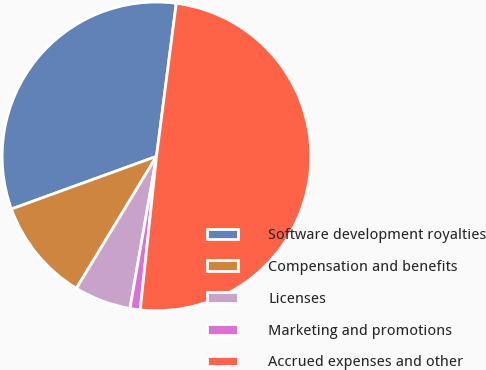Convert chart to OTSL. <chart><loc_0><loc_0><loc_500><loc_500><pie_chart><fcel>Software development royalties<fcel>Compensation and benefits<fcel>Licenses<fcel>Marketing and promotions<fcel>Accrued expenses and other<nl><fcel>32.58%<fcel>10.78%<fcel>5.93%<fcel>1.07%<fcel>49.63%<nl></chart> 